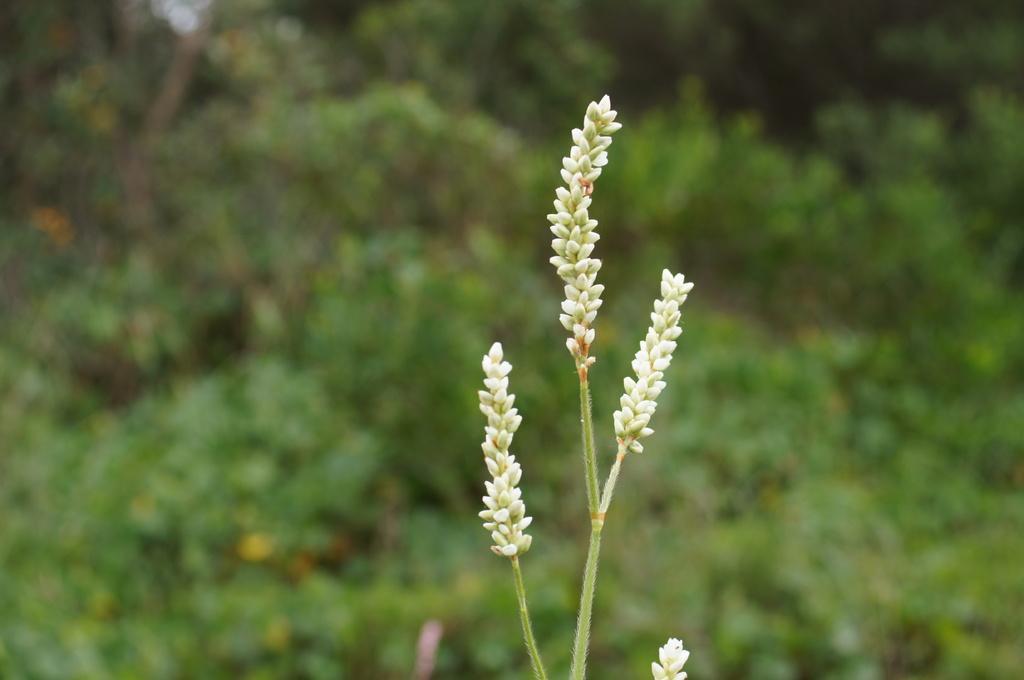Could you give a brief overview of what you see in this image? In this image in the foreground there are some flowers, and in the background there are plants. 